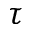Convert formula to latex. <formula><loc_0><loc_0><loc_500><loc_500>\tau</formula> 